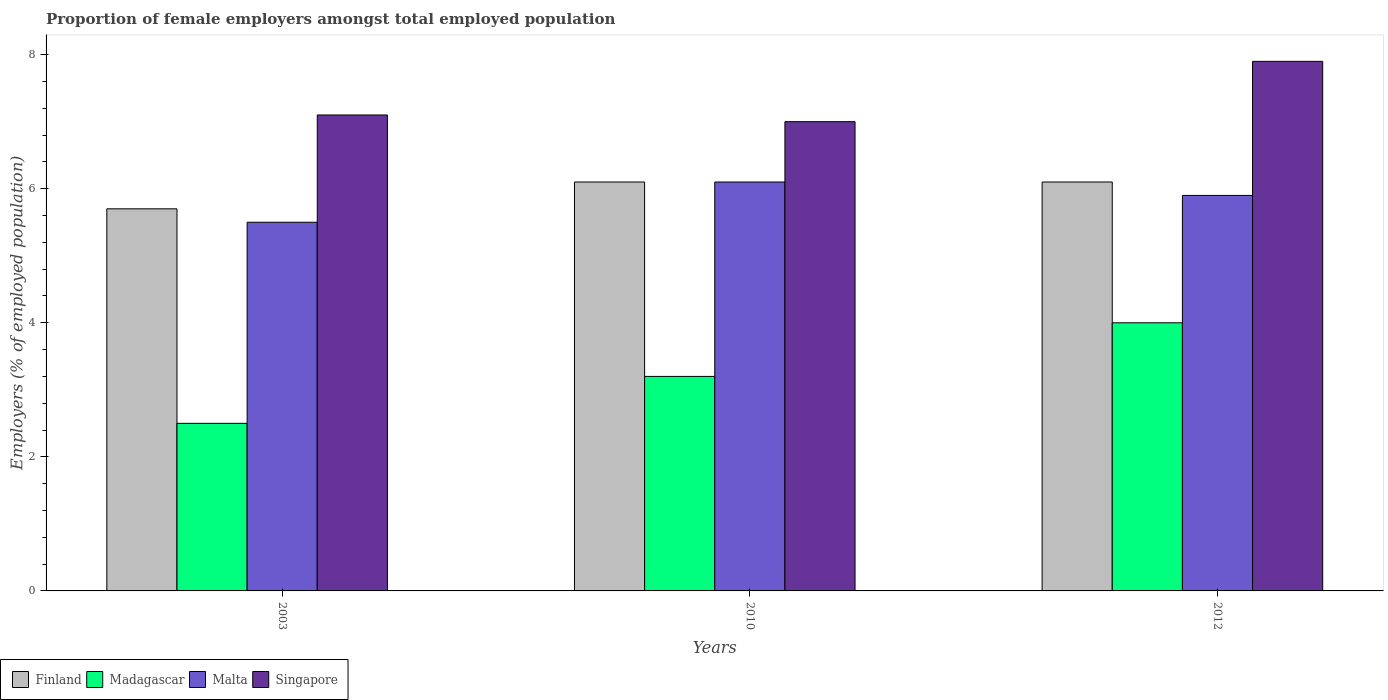How many different coloured bars are there?
Offer a very short reply. 4. How many bars are there on the 1st tick from the right?
Provide a short and direct response. 4. What is the label of the 3rd group of bars from the left?
Your answer should be compact. 2012. In how many cases, is the number of bars for a given year not equal to the number of legend labels?
Your answer should be compact. 0. What is the proportion of female employers in Singapore in 2012?
Your answer should be very brief. 7.9. Across all years, what is the maximum proportion of female employers in Singapore?
Give a very brief answer. 7.9. Across all years, what is the minimum proportion of female employers in Singapore?
Provide a short and direct response. 7. In which year was the proportion of female employers in Madagascar maximum?
Make the answer very short. 2012. What is the difference between the proportion of female employers in Singapore in 2010 and that in 2012?
Provide a short and direct response. -0.9. What is the difference between the proportion of female employers in Finland in 2003 and the proportion of female employers in Madagascar in 2012?
Offer a very short reply. 1.7. What is the average proportion of female employers in Singapore per year?
Provide a succinct answer. 7.33. In the year 2003, what is the difference between the proportion of female employers in Finland and proportion of female employers in Madagascar?
Keep it short and to the point. 3.2. What is the ratio of the proportion of female employers in Finland in 2003 to that in 2012?
Keep it short and to the point. 0.93. Is the difference between the proportion of female employers in Finland in 2003 and 2010 greater than the difference between the proportion of female employers in Madagascar in 2003 and 2010?
Offer a very short reply. Yes. What is the difference between the highest and the second highest proportion of female employers in Madagascar?
Give a very brief answer. 0.8. What is the difference between the highest and the lowest proportion of female employers in Finland?
Ensure brevity in your answer.  0.4. In how many years, is the proportion of female employers in Finland greater than the average proportion of female employers in Finland taken over all years?
Make the answer very short. 2. Is it the case that in every year, the sum of the proportion of female employers in Malta and proportion of female employers in Madagascar is greater than the sum of proportion of female employers in Singapore and proportion of female employers in Finland?
Keep it short and to the point. Yes. What does the 1st bar from the left in 2003 represents?
Your answer should be very brief. Finland. What does the 2nd bar from the right in 2003 represents?
Provide a short and direct response. Malta. How many bars are there?
Make the answer very short. 12. Are all the bars in the graph horizontal?
Your answer should be very brief. No. Does the graph contain any zero values?
Offer a very short reply. No. Does the graph contain grids?
Provide a succinct answer. No. Where does the legend appear in the graph?
Ensure brevity in your answer.  Bottom left. How many legend labels are there?
Ensure brevity in your answer.  4. What is the title of the graph?
Give a very brief answer. Proportion of female employers amongst total employed population. Does "World" appear as one of the legend labels in the graph?
Offer a terse response. No. What is the label or title of the X-axis?
Give a very brief answer. Years. What is the label or title of the Y-axis?
Provide a succinct answer. Employers (% of employed population). What is the Employers (% of employed population) in Finland in 2003?
Your response must be concise. 5.7. What is the Employers (% of employed population) of Madagascar in 2003?
Make the answer very short. 2.5. What is the Employers (% of employed population) in Malta in 2003?
Provide a succinct answer. 5.5. What is the Employers (% of employed population) in Singapore in 2003?
Your response must be concise. 7.1. What is the Employers (% of employed population) in Finland in 2010?
Keep it short and to the point. 6.1. What is the Employers (% of employed population) in Madagascar in 2010?
Make the answer very short. 3.2. What is the Employers (% of employed population) of Malta in 2010?
Provide a succinct answer. 6.1. What is the Employers (% of employed population) in Singapore in 2010?
Give a very brief answer. 7. What is the Employers (% of employed population) in Finland in 2012?
Provide a succinct answer. 6.1. What is the Employers (% of employed population) in Madagascar in 2012?
Your response must be concise. 4. What is the Employers (% of employed population) of Malta in 2012?
Ensure brevity in your answer.  5.9. What is the Employers (% of employed population) in Singapore in 2012?
Your response must be concise. 7.9. Across all years, what is the maximum Employers (% of employed population) of Finland?
Provide a succinct answer. 6.1. Across all years, what is the maximum Employers (% of employed population) of Malta?
Your response must be concise. 6.1. Across all years, what is the maximum Employers (% of employed population) in Singapore?
Make the answer very short. 7.9. Across all years, what is the minimum Employers (% of employed population) in Finland?
Your answer should be very brief. 5.7. Across all years, what is the minimum Employers (% of employed population) in Malta?
Your answer should be very brief. 5.5. Across all years, what is the minimum Employers (% of employed population) in Singapore?
Your answer should be compact. 7. What is the total Employers (% of employed population) of Madagascar in the graph?
Give a very brief answer. 9.7. What is the total Employers (% of employed population) in Malta in the graph?
Make the answer very short. 17.5. What is the difference between the Employers (% of employed population) in Finland in 2003 and that in 2012?
Offer a very short reply. -0.4. What is the difference between the Employers (% of employed population) of Madagascar in 2003 and that in 2012?
Give a very brief answer. -1.5. What is the difference between the Employers (% of employed population) of Malta in 2003 and that in 2012?
Offer a very short reply. -0.4. What is the difference between the Employers (% of employed population) in Madagascar in 2010 and that in 2012?
Your answer should be compact. -0.8. What is the difference between the Employers (% of employed population) in Malta in 2010 and that in 2012?
Give a very brief answer. 0.2. What is the difference between the Employers (% of employed population) in Singapore in 2010 and that in 2012?
Make the answer very short. -0.9. What is the difference between the Employers (% of employed population) of Finland in 2003 and the Employers (% of employed population) of Madagascar in 2010?
Your answer should be compact. 2.5. What is the difference between the Employers (% of employed population) in Madagascar in 2003 and the Employers (% of employed population) in Malta in 2012?
Keep it short and to the point. -3.4. What is the difference between the Employers (% of employed population) of Malta in 2003 and the Employers (% of employed population) of Singapore in 2012?
Give a very brief answer. -2.4. What is the difference between the Employers (% of employed population) of Finland in 2010 and the Employers (% of employed population) of Madagascar in 2012?
Provide a short and direct response. 2.1. What is the difference between the Employers (% of employed population) of Madagascar in 2010 and the Employers (% of employed population) of Malta in 2012?
Your response must be concise. -2.7. What is the average Employers (% of employed population) in Finland per year?
Offer a terse response. 5.97. What is the average Employers (% of employed population) of Madagascar per year?
Offer a terse response. 3.23. What is the average Employers (% of employed population) in Malta per year?
Your response must be concise. 5.83. What is the average Employers (% of employed population) of Singapore per year?
Your response must be concise. 7.33. In the year 2003, what is the difference between the Employers (% of employed population) in Madagascar and Employers (% of employed population) in Malta?
Make the answer very short. -3. In the year 2003, what is the difference between the Employers (% of employed population) in Malta and Employers (% of employed population) in Singapore?
Your answer should be very brief. -1.6. In the year 2010, what is the difference between the Employers (% of employed population) of Finland and Employers (% of employed population) of Madagascar?
Keep it short and to the point. 2.9. In the year 2010, what is the difference between the Employers (% of employed population) of Finland and Employers (% of employed population) of Singapore?
Your answer should be very brief. -0.9. In the year 2010, what is the difference between the Employers (% of employed population) of Malta and Employers (% of employed population) of Singapore?
Keep it short and to the point. -0.9. What is the ratio of the Employers (% of employed population) in Finland in 2003 to that in 2010?
Ensure brevity in your answer.  0.93. What is the ratio of the Employers (% of employed population) of Madagascar in 2003 to that in 2010?
Make the answer very short. 0.78. What is the ratio of the Employers (% of employed population) of Malta in 2003 to that in 2010?
Your answer should be compact. 0.9. What is the ratio of the Employers (% of employed population) of Singapore in 2003 to that in 2010?
Provide a short and direct response. 1.01. What is the ratio of the Employers (% of employed population) in Finland in 2003 to that in 2012?
Offer a very short reply. 0.93. What is the ratio of the Employers (% of employed population) of Madagascar in 2003 to that in 2012?
Ensure brevity in your answer.  0.62. What is the ratio of the Employers (% of employed population) in Malta in 2003 to that in 2012?
Keep it short and to the point. 0.93. What is the ratio of the Employers (% of employed population) in Singapore in 2003 to that in 2012?
Provide a short and direct response. 0.9. What is the ratio of the Employers (% of employed population) in Madagascar in 2010 to that in 2012?
Offer a terse response. 0.8. What is the ratio of the Employers (% of employed population) in Malta in 2010 to that in 2012?
Keep it short and to the point. 1.03. What is the ratio of the Employers (% of employed population) in Singapore in 2010 to that in 2012?
Provide a succinct answer. 0.89. What is the difference between the highest and the second highest Employers (% of employed population) in Finland?
Keep it short and to the point. 0. What is the difference between the highest and the second highest Employers (% of employed population) of Madagascar?
Offer a very short reply. 0.8. What is the difference between the highest and the lowest Employers (% of employed population) of Finland?
Make the answer very short. 0.4. What is the difference between the highest and the lowest Employers (% of employed population) in Singapore?
Your answer should be very brief. 0.9. 